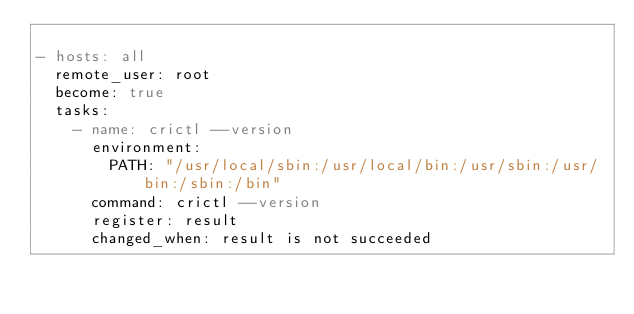<code> <loc_0><loc_0><loc_500><loc_500><_YAML_>
- hosts: all
  remote_user: root
  become: true
  tasks:
    - name: crictl --version
      environment:
        PATH: "/usr/local/sbin:/usr/local/bin:/usr/sbin:/usr/bin:/sbin:/bin"
      command: crictl --version
      register: result
      changed_when: result is not succeeded
</code> 